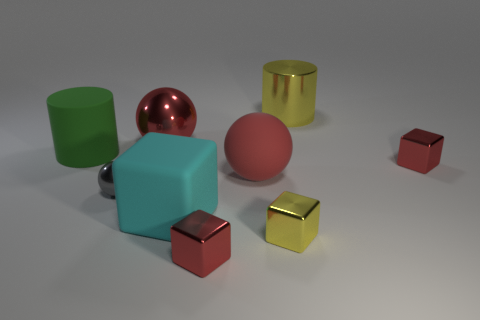Subtract all gray cubes. Subtract all purple cylinders. How many cubes are left? 4 Subtract all blocks. How many objects are left? 5 Add 8 green things. How many green things exist? 9 Subtract 0 blue cubes. How many objects are left? 9 Subtract all cyan cubes. Subtract all large green rubber cylinders. How many objects are left? 7 Add 1 matte spheres. How many matte spheres are left? 2 